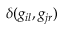<formula> <loc_0><loc_0><loc_500><loc_500>\delta ( g _ { i l } , g _ { j r } )</formula> 